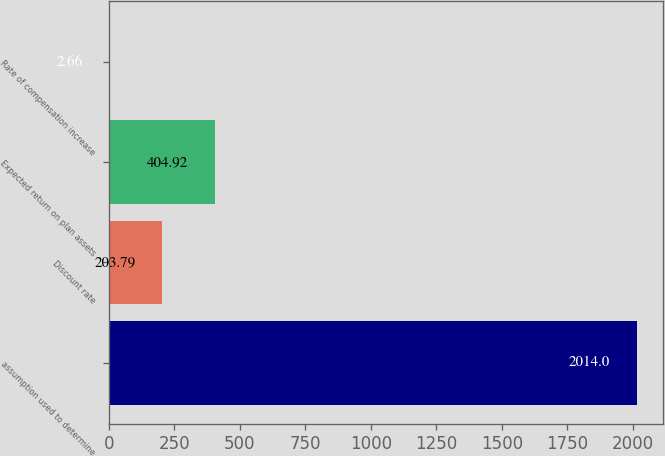Convert chart to OTSL. <chart><loc_0><loc_0><loc_500><loc_500><bar_chart><fcel>assumption used to determine<fcel>Discount rate<fcel>Expected return on plan assets<fcel>Rate of compensation increase<nl><fcel>2014<fcel>203.79<fcel>404.92<fcel>2.66<nl></chart> 